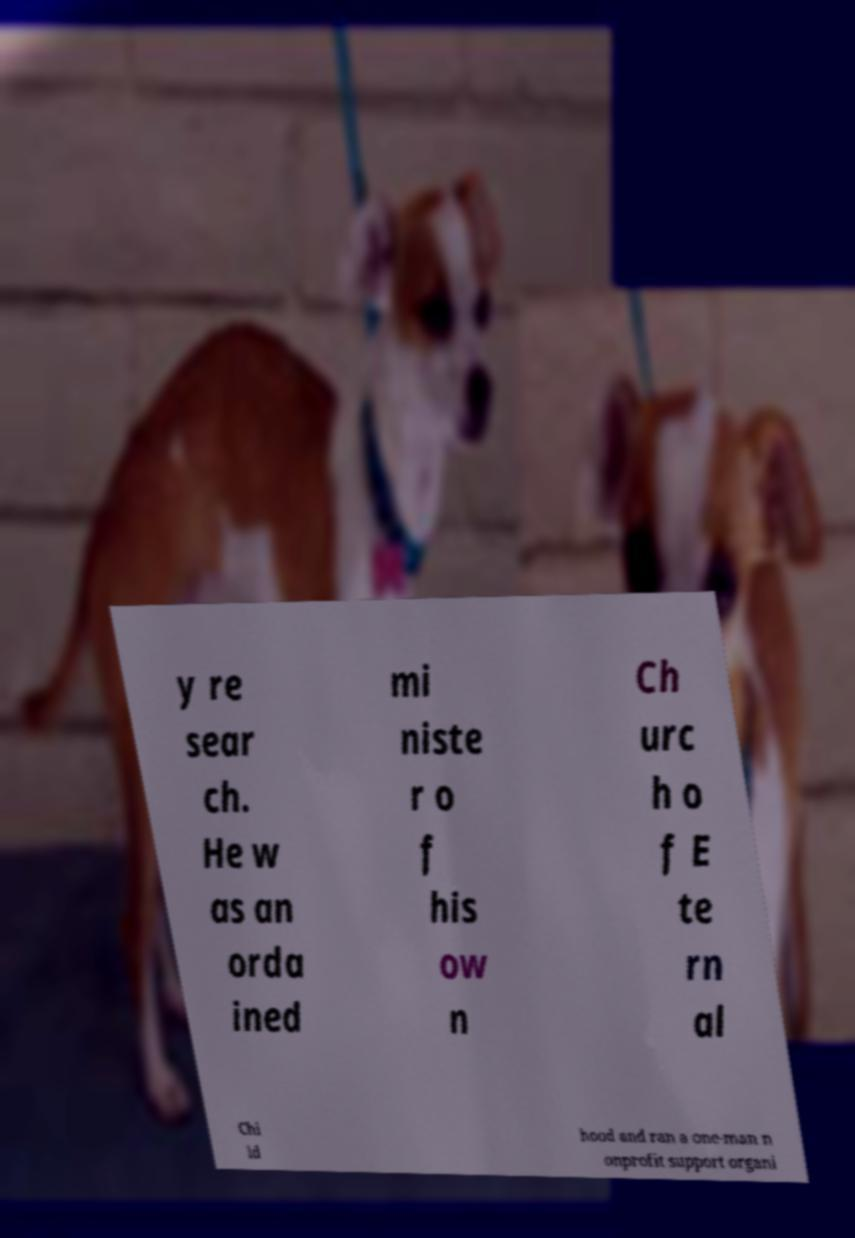Can you accurately transcribe the text from the provided image for me? y re sear ch. He w as an orda ined mi niste r o f his ow n Ch urc h o f E te rn al Chi ld hood and ran a one-man n onprofit support organi 